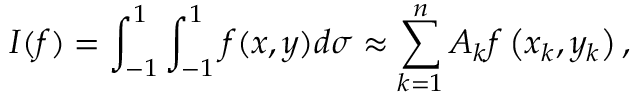Convert formula to latex. <formula><loc_0><loc_0><loc_500><loc_500>I ( f ) = \int _ { - 1 } ^ { 1 } \int _ { - 1 } ^ { 1 } f ( x , y ) d \sigma \approx \sum _ { k = 1 } ^ { n } A _ { k } f \left ( x _ { k } , y _ { k } \right ) ,</formula> 